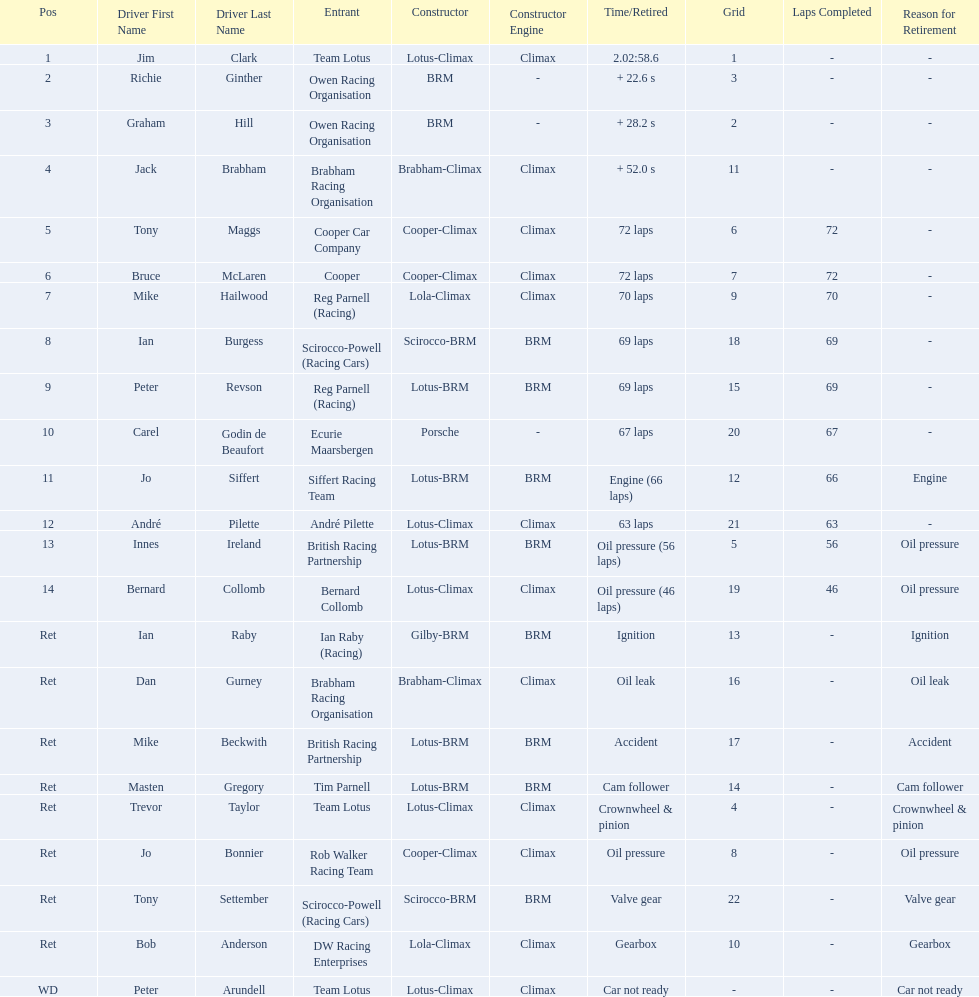Who are all the drivers? Jim Clark, Richie Ginther, Graham Hill, Jack Brabham, Tony Maggs, Bruce McLaren, Mike Hailwood, Ian Burgess, Peter Revson, Carel Godin de Beaufort, Jo Siffert, André Pilette, Innes Ireland, Bernard Collomb, Ian Raby, Dan Gurney, Mike Beckwith, Masten Gregory, Trevor Taylor, Jo Bonnier, Tony Settember, Bob Anderson, Peter Arundell. What were their positions? 1, 2, 3, 4, 5, 6, 7, 8, 9, 10, 11, 12, 13, 14, Ret, Ret, Ret, Ret, Ret, Ret, Ret, Ret, WD. What are all the constructor names? Lotus-Climax, BRM, BRM, Brabham-Climax, Cooper-Climax, Cooper-Climax, Lola-Climax, Scirocco-BRM, Lotus-BRM, Porsche, Lotus-BRM, Lotus-Climax, Lotus-BRM, Lotus-Climax, Gilby-BRM, Brabham-Climax, Lotus-BRM, Lotus-BRM, Lotus-Climax, Cooper-Climax, Scirocco-BRM, Lola-Climax, Lotus-Climax. And which drivers drove a cooper-climax? Tony Maggs, Bruce McLaren. Between those tow, who was positioned higher? Tony Maggs. 